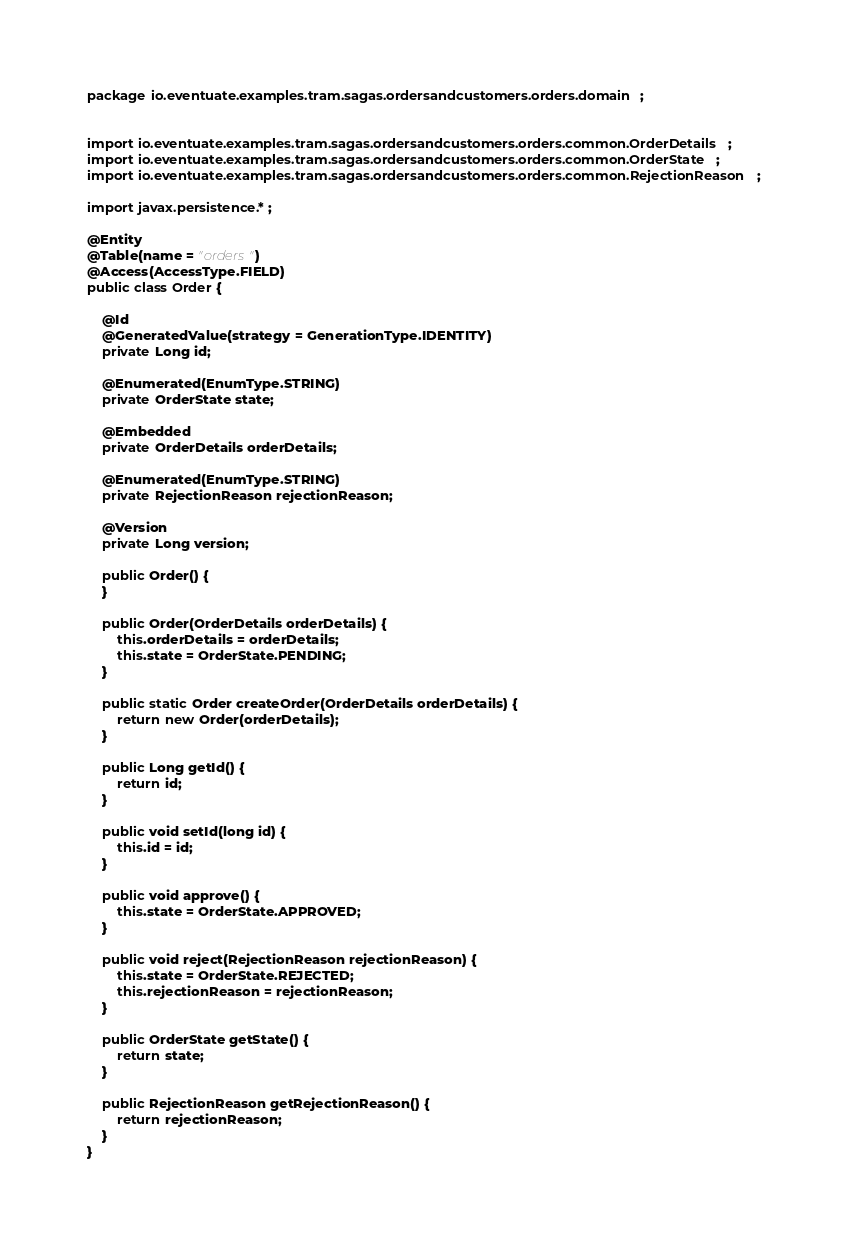<code> <loc_0><loc_0><loc_500><loc_500><_Java_>package io.eventuate.examples.tram.sagas.ordersandcustomers.orders.domain;


import io.eventuate.examples.tram.sagas.ordersandcustomers.orders.common.OrderDetails;
import io.eventuate.examples.tram.sagas.ordersandcustomers.orders.common.OrderState;
import io.eventuate.examples.tram.sagas.ordersandcustomers.orders.common.RejectionReason;

import javax.persistence.*;

@Entity
@Table(name = "orders")
@Access(AccessType.FIELD)
public class Order {

    @Id
    @GeneratedValue(strategy = GenerationType.IDENTITY)
    private Long id;

    @Enumerated(EnumType.STRING)
    private OrderState state;

    @Embedded
    private OrderDetails orderDetails;

    @Enumerated(EnumType.STRING)
    private RejectionReason rejectionReason;

    @Version
    private Long version;

    public Order() {
    }

    public Order(OrderDetails orderDetails) {
        this.orderDetails = orderDetails;
        this.state = OrderState.PENDING;
    }

    public static Order createOrder(OrderDetails orderDetails) {
        return new Order(orderDetails);
    }

    public Long getId() {
        return id;
    }

    public void setId(long id) {
        this.id = id;
    }

    public void approve() {
        this.state = OrderState.APPROVED;
    }

    public void reject(RejectionReason rejectionReason) {
        this.state = OrderState.REJECTED;
        this.rejectionReason = rejectionReason;
    }

    public OrderState getState() {
        return state;
    }

    public RejectionReason getRejectionReason() {
        return rejectionReason;
    }
}
</code> 